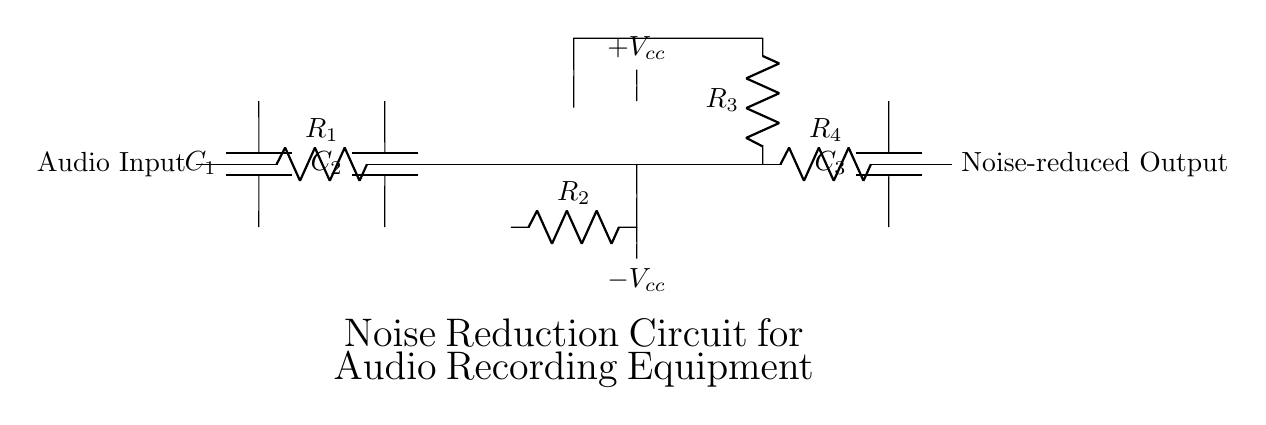What is the function of capacitor C1? Capacitor C1 acts as a coupling capacitor, allowing AC signals to pass while blocking DC offset from the audio input, which is essential for maintaining sound quality.
Answer: Coupling What does the operational amplifier do in this circuit? The operational amplifier amplifies the audio signal, improving the signal-to-noise ratio, which is crucial for noise reduction in recording equipment.
Answer: Amplification How many resistors are in the circuit? Counting all the resistors labeled R in the diagram, there are four distinct resistors present in the circuit.
Answer: Four What type of filters are used in this circuit? The circuit utilizes a high-pass filter (formed by R1 and C2) to eliminate low-frequency noise, and a low-pass filter (formed by R4 and C3) to remove high-frequency noise, ensuring a clean audio output.
Answer: High-pass and low-pass What are the power supply voltages for the op-amp? The operational amplifier requires a dual power supply, indicated as plus Vcc and minus Vcc, which provides the necessary voltage levels for proper functioning of the amplifier.
Answer: Plus Vcc and minus Vcc Which components make up the audio input stage? The audio input stage consists of the coupling capacitor C1 and resistor R1, which together form the effective entry point for the audio signal into the circuit.
Answer: C1 and R1 